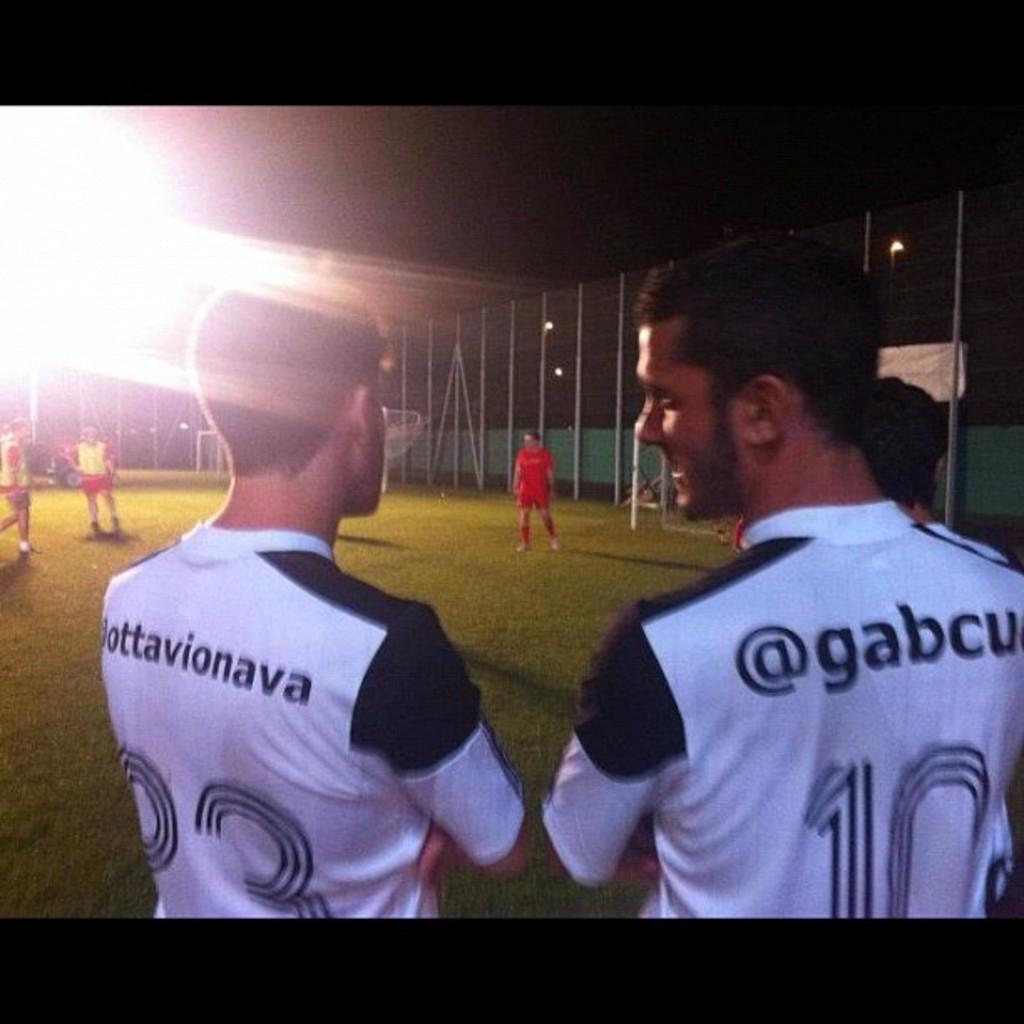What is the name of player 10?
Give a very brief answer. Gabcu. 